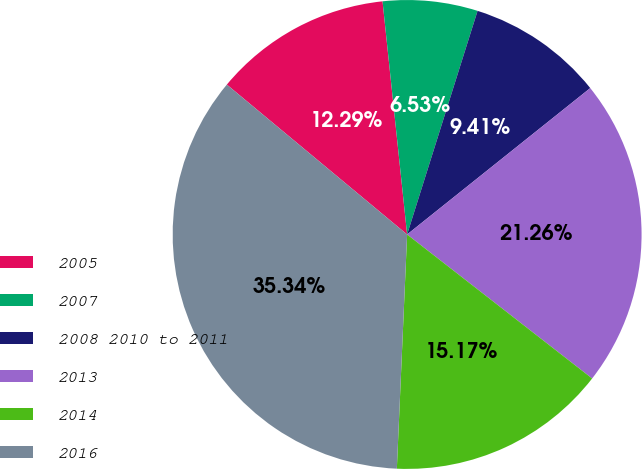Convert chart to OTSL. <chart><loc_0><loc_0><loc_500><loc_500><pie_chart><fcel>2005<fcel>2007<fcel>2008 2010 to 2011<fcel>2013<fcel>2014<fcel>2016<nl><fcel>12.29%<fcel>6.53%<fcel>9.41%<fcel>21.26%<fcel>15.17%<fcel>35.34%<nl></chart> 